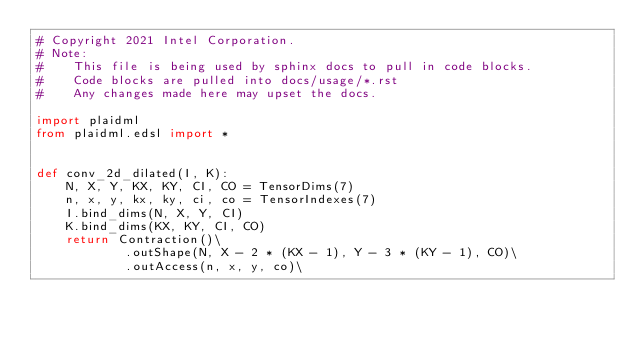<code> <loc_0><loc_0><loc_500><loc_500><_Python_># Copyright 2021 Intel Corporation.
# Note:
#    This file is being used by sphinx docs to pull in code blocks.
#    Code blocks are pulled into docs/usage/*.rst
#    Any changes made here may upset the docs.

import plaidml
from plaidml.edsl import *


def conv_2d_dilated(I, K):
    N, X, Y, KX, KY, CI, CO = TensorDims(7)
    n, x, y, kx, ky, ci, co = TensorIndexes(7)
    I.bind_dims(N, X, Y, CI)
    K.bind_dims(KX, KY, CI, CO)
    return Contraction()\
            .outShape(N, X - 2 * (KX - 1), Y - 3 * (KY - 1), CO)\
            .outAccess(n, x, y, co)\</code> 